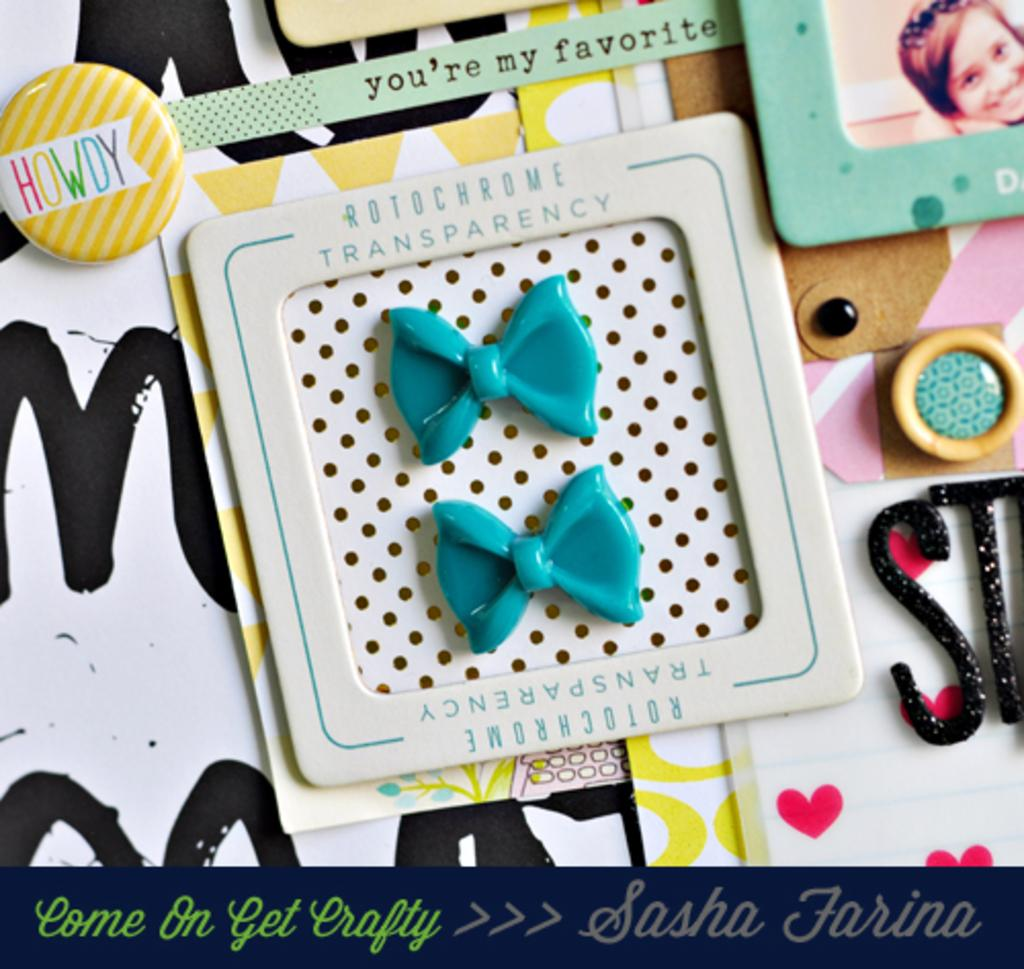What is the main object in the image? There is a badge in the image. What is the badge placed in? The badge is placed in a frame in the image. What is depicted in the frame? There is a picture of a person in the image. What else can be seen in the image besides the badge and frame? There are objects in the image. What information is provided at the bottom of the image? There is text written at the bottom of the image. How many lace curtains are hanging in the image? There are no lace curtains present in the image. What type of trucks are visible in the image? There are no trucks visible in the image. 